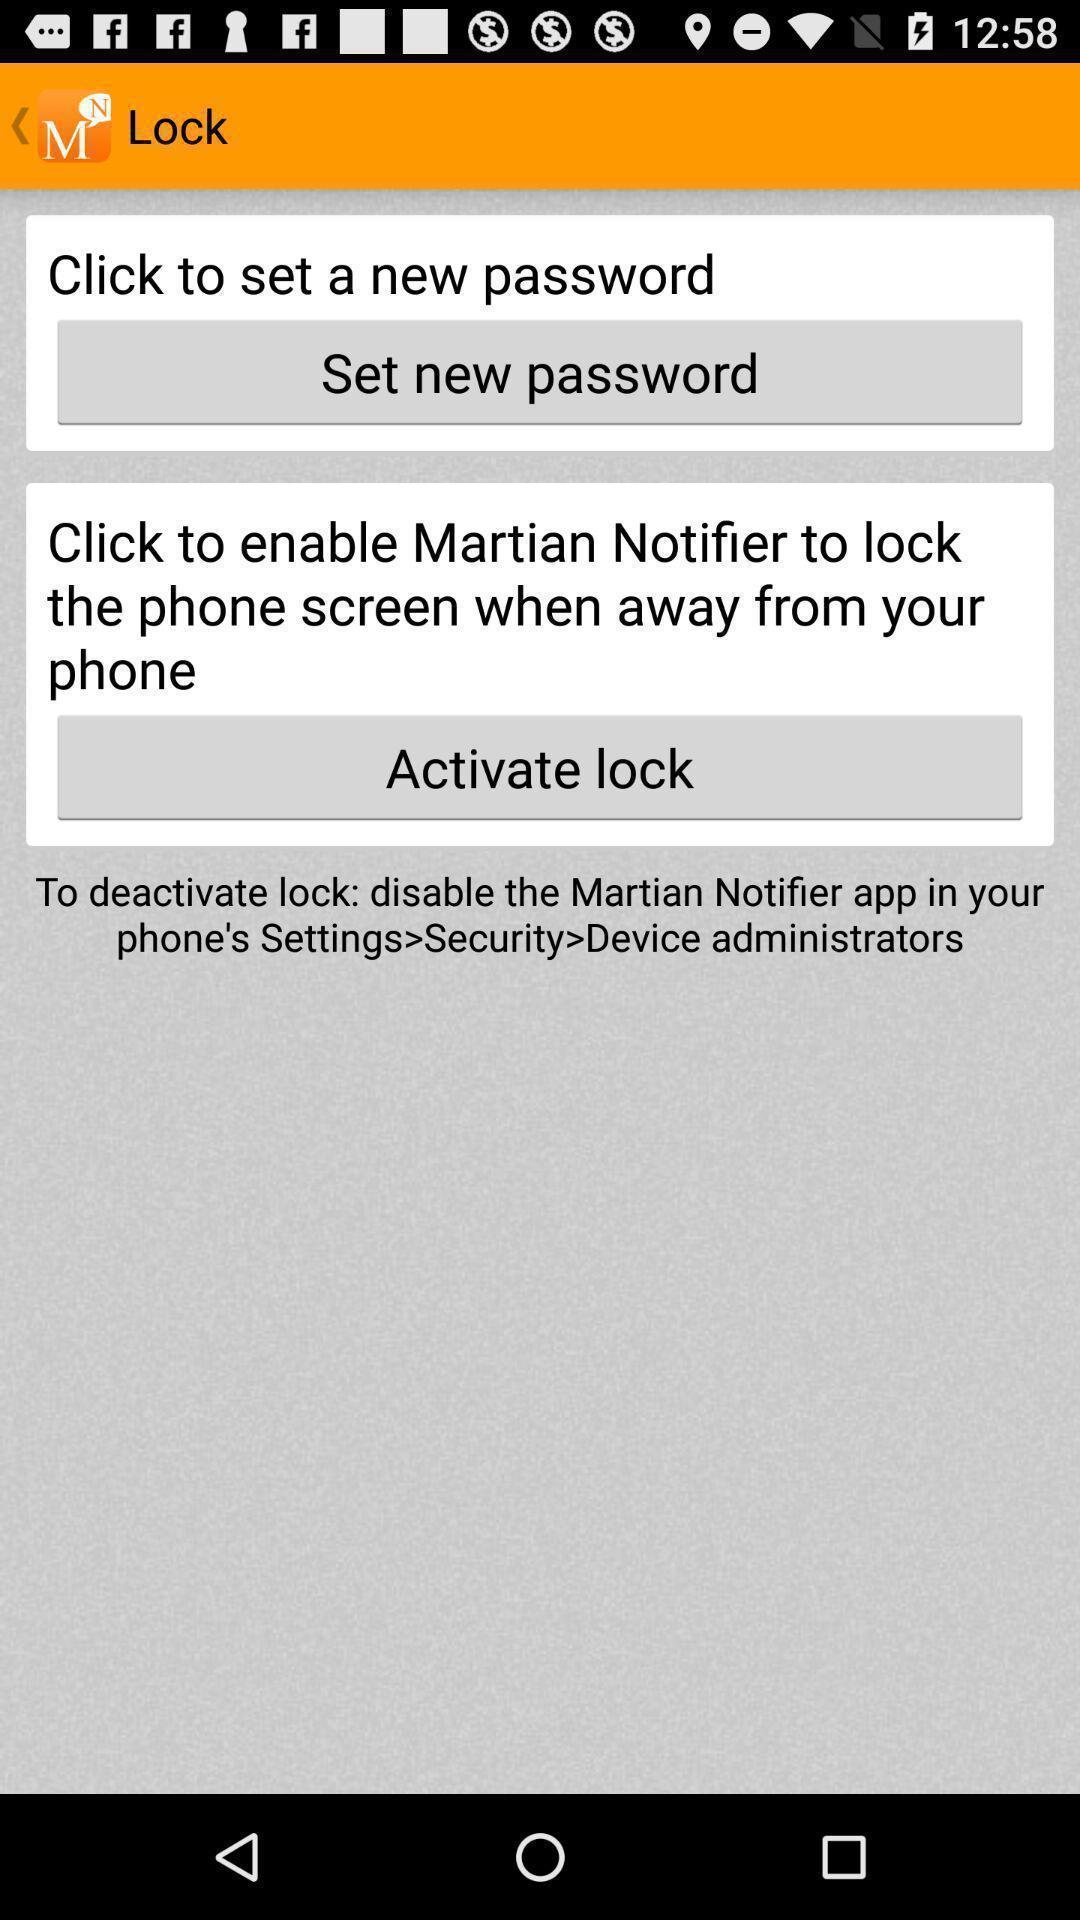Explain the elements present in this screenshot. Two features are displaying in security providing app. 